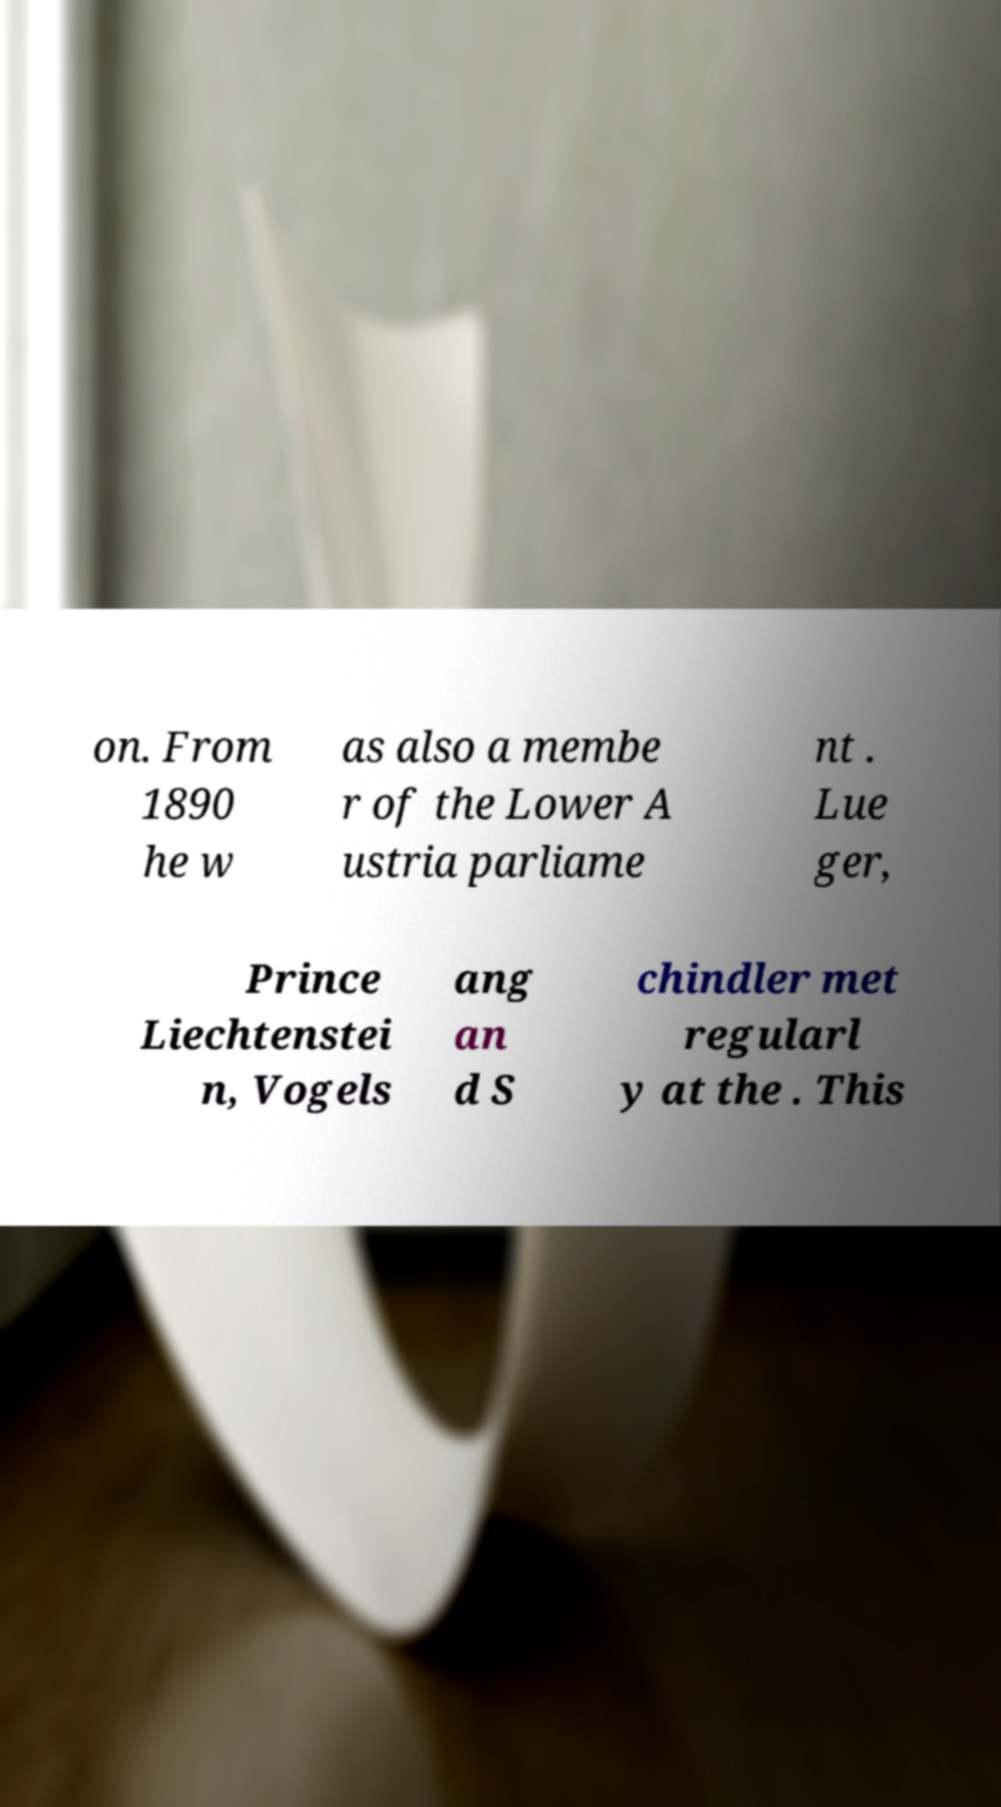For documentation purposes, I need the text within this image transcribed. Could you provide that? on. From 1890 he w as also a membe r of the Lower A ustria parliame nt . Lue ger, Prince Liechtenstei n, Vogels ang an d S chindler met regularl y at the . This 